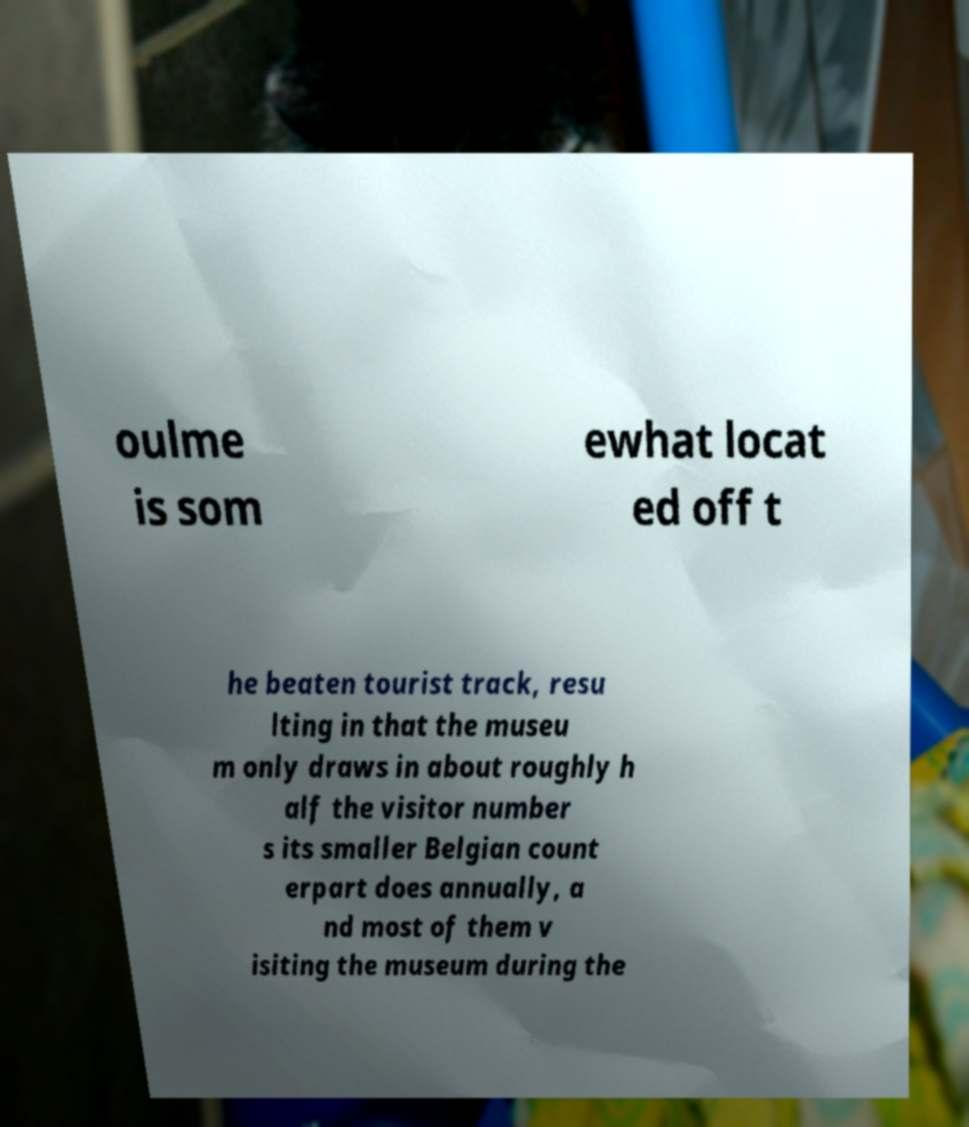Can you read and provide the text displayed in the image?This photo seems to have some interesting text. Can you extract and type it out for me? oulme is som ewhat locat ed off t he beaten tourist track, resu lting in that the museu m only draws in about roughly h alf the visitor number s its smaller Belgian count erpart does annually, a nd most of them v isiting the museum during the 